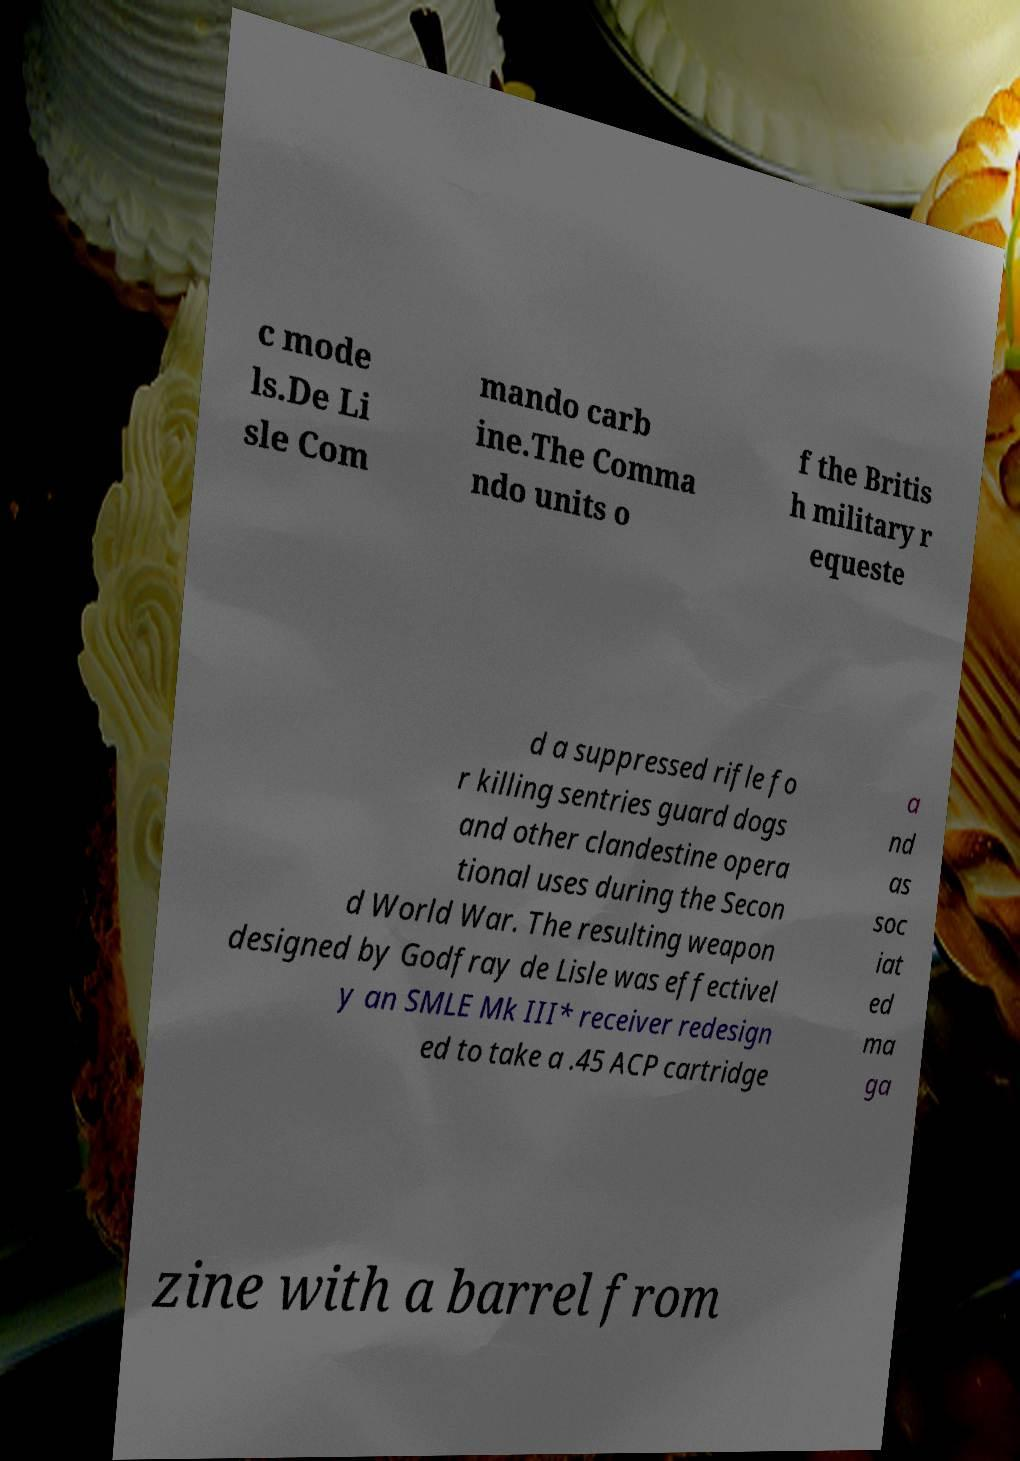Please read and relay the text visible in this image. What does it say? c mode ls.De Li sle Com mando carb ine.The Comma ndo units o f the Britis h military r equeste d a suppressed rifle fo r killing sentries guard dogs and other clandestine opera tional uses during the Secon d World War. The resulting weapon designed by Godfray de Lisle was effectivel y an SMLE Mk III* receiver redesign ed to take a .45 ACP cartridge a nd as soc iat ed ma ga zine with a barrel from 